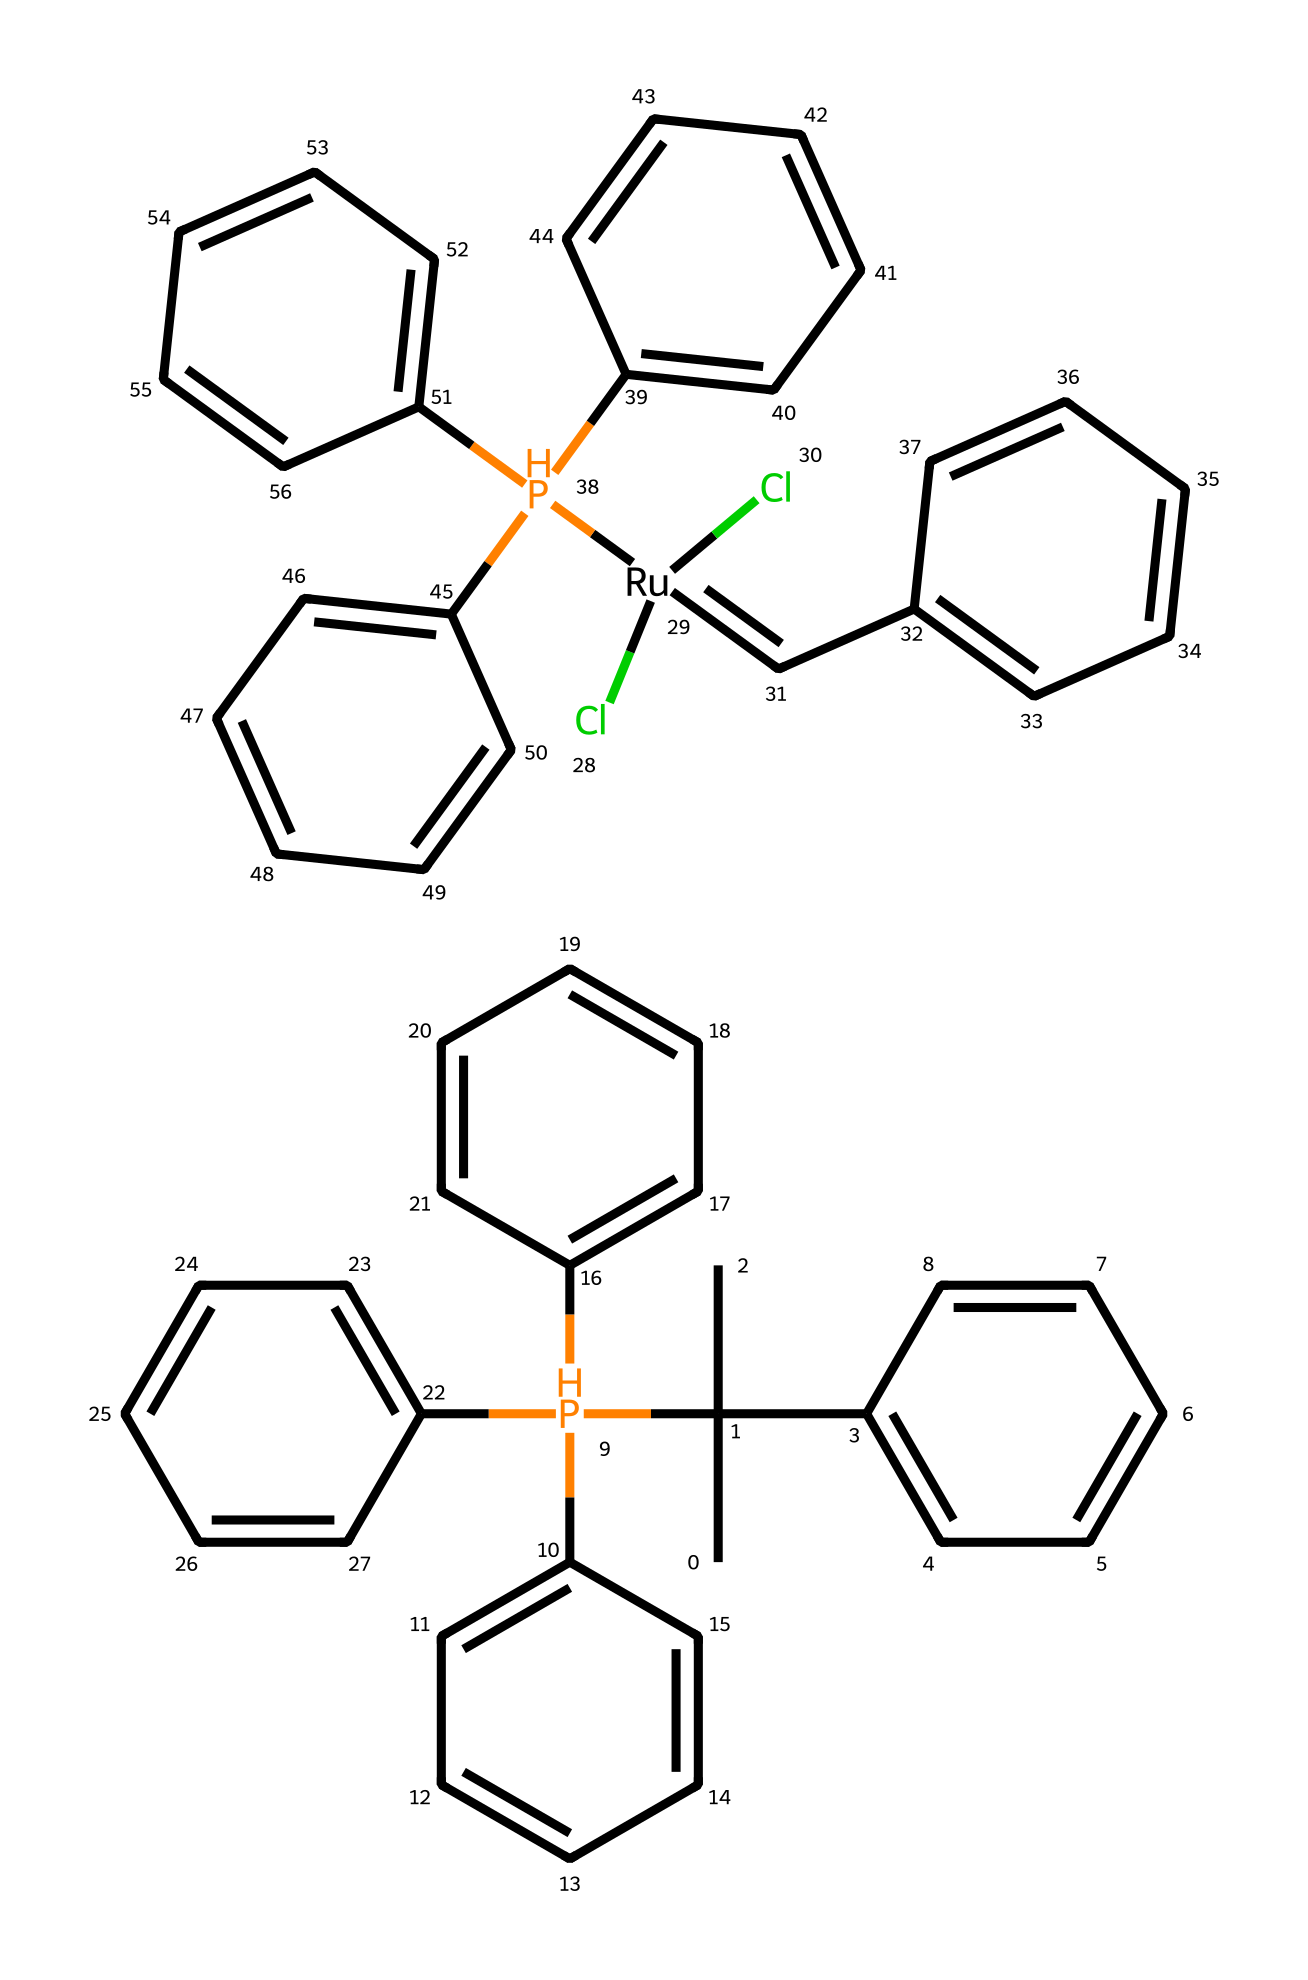What is the central metallic atom in this compound? The structure contains a ruthenium (Ru) atom, which is typically found at the center of organometallic complexes and acts as the catalyst in olefin metathesis reactions.
Answer: ruthenium How many phosphine ligands are attached to the central metal? There are four phosphine (P) ligands depicted in the structure, which provide electron pairs to stabilize the ruthenium center.
Answer: four What type of reaction is this compound primarily used for? The compound is primarily used in olefin metathesis, which involves the exchange of carbon-carbon double bonds.
Answer: olefin metathesis How many cyclic structures are present in the compound? Upon examining the structure, there are five distinct cyclic structures (aromatic rings) that contribute to the overall complexity of the compound.
Answer: five What role do phosphine ligands play in this organometallic compound? Phosphine ligands serve as electron-donating species that stabilize the metal center and facilitate the reactivity of the catalyst.
Answer: stabilization Which functional group is prominently featured in this organometallic compound? The compound prominently features multiple olefin (alkene) groups, indicated by the presence of carbon-carbon double bonds within the structure.
Answer: olefin 